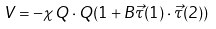Convert formula to latex. <formula><loc_0><loc_0><loc_500><loc_500>V = - \chi Q \cdot Q ( 1 + B \vec { \tau } ( 1 ) \cdot \vec { \tau } ( 2 ) )</formula> 